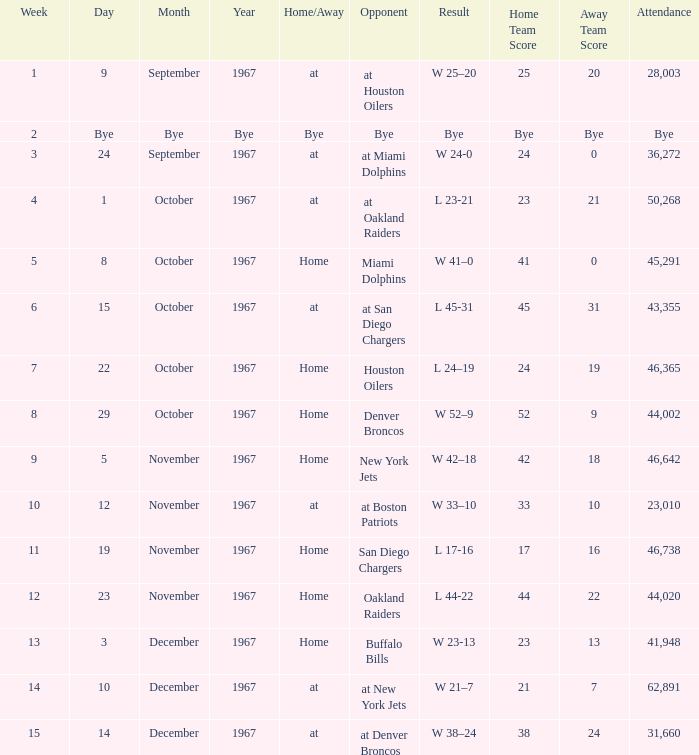What week did the September 9, 1967 game occur on? 1.0. 